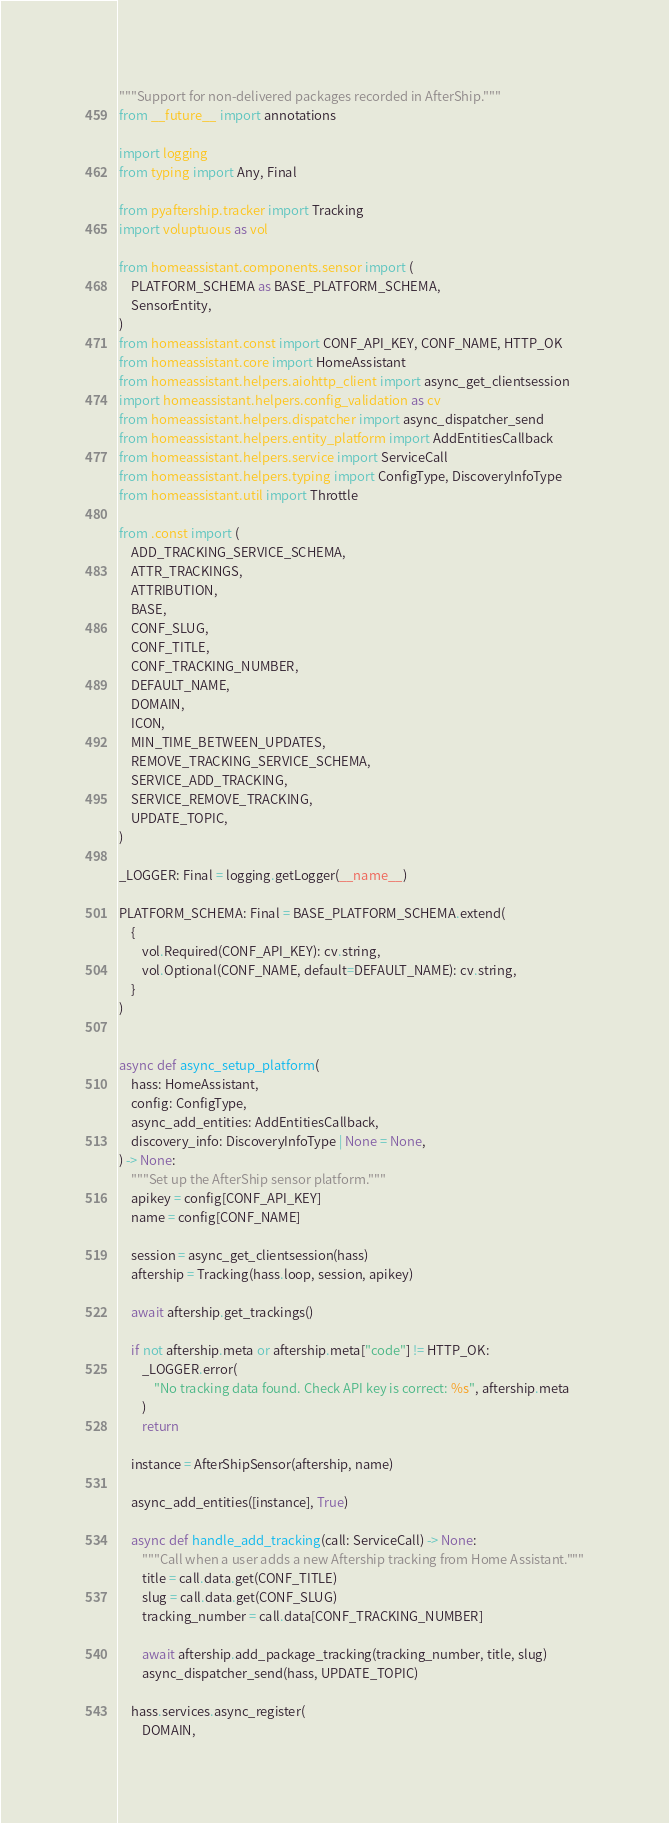Convert code to text. <code><loc_0><loc_0><loc_500><loc_500><_Python_>"""Support for non-delivered packages recorded in AfterShip."""
from __future__ import annotations

import logging
from typing import Any, Final

from pyaftership.tracker import Tracking
import voluptuous as vol

from homeassistant.components.sensor import (
    PLATFORM_SCHEMA as BASE_PLATFORM_SCHEMA,
    SensorEntity,
)
from homeassistant.const import CONF_API_KEY, CONF_NAME, HTTP_OK
from homeassistant.core import HomeAssistant
from homeassistant.helpers.aiohttp_client import async_get_clientsession
import homeassistant.helpers.config_validation as cv
from homeassistant.helpers.dispatcher import async_dispatcher_send
from homeassistant.helpers.entity_platform import AddEntitiesCallback
from homeassistant.helpers.service import ServiceCall
from homeassistant.helpers.typing import ConfigType, DiscoveryInfoType
from homeassistant.util import Throttle

from .const import (
    ADD_TRACKING_SERVICE_SCHEMA,
    ATTR_TRACKINGS,
    ATTRIBUTION,
    BASE,
    CONF_SLUG,
    CONF_TITLE,
    CONF_TRACKING_NUMBER,
    DEFAULT_NAME,
    DOMAIN,
    ICON,
    MIN_TIME_BETWEEN_UPDATES,
    REMOVE_TRACKING_SERVICE_SCHEMA,
    SERVICE_ADD_TRACKING,
    SERVICE_REMOVE_TRACKING,
    UPDATE_TOPIC,
)

_LOGGER: Final = logging.getLogger(__name__)

PLATFORM_SCHEMA: Final = BASE_PLATFORM_SCHEMA.extend(
    {
        vol.Required(CONF_API_KEY): cv.string,
        vol.Optional(CONF_NAME, default=DEFAULT_NAME): cv.string,
    }
)


async def async_setup_platform(
    hass: HomeAssistant,
    config: ConfigType,
    async_add_entities: AddEntitiesCallback,
    discovery_info: DiscoveryInfoType | None = None,
) -> None:
    """Set up the AfterShip sensor platform."""
    apikey = config[CONF_API_KEY]
    name = config[CONF_NAME]

    session = async_get_clientsession(hass)
    aftership = Tracking(hass.loop, session, apikey)

    await aftership.get_trackings()

    if not aftership.meta or aftership.meta["code"] != HTTP_OK:
        _LOGGER.error(
            "No tracking data found. Check API key is correct: %s", aftership.meta
        )
        return

    instance = AfterShipSensor(aftership, name)

    async_add_entities([instance], True)

    async def handle_add_tracking(call: ServiceCall) -> None:
        """Call when a user adds a new Aftership tracking from Home Assistant."""
        title = call.data.get(CONF_TITLE)
        slug = call.data.get(CONF_SLUG)
        tracking_number = call.data[CONF_TRACKING_NUMBER]

        await aftership.add_package_tracking(tracking_number, title, slug)
        async_dispatcher_send(hass, UPDATE_TOPIC)

    hass.services.async_register(
        DOMAIN,</code> 